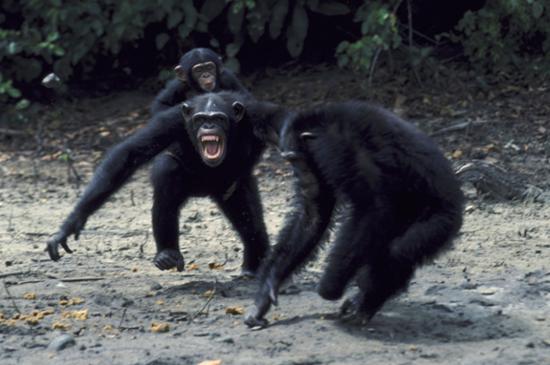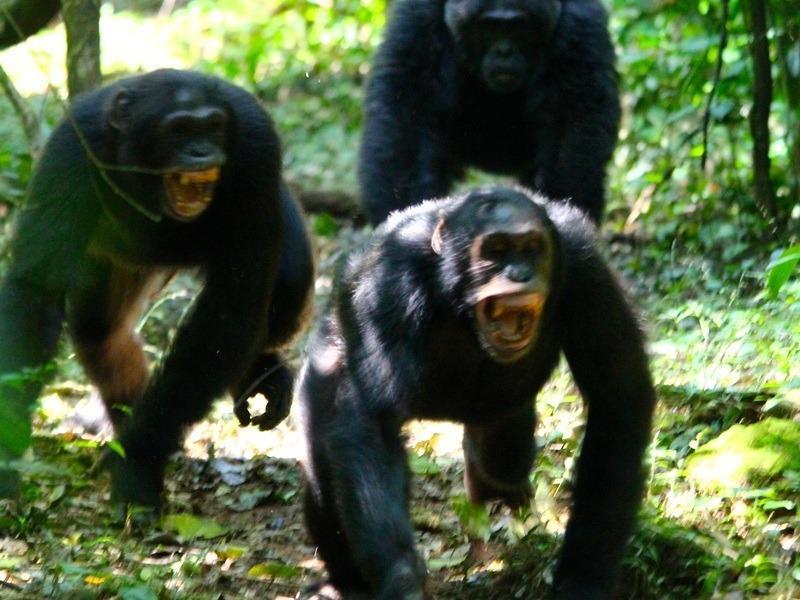The first image is the image on the left, the second image is the image on the right. For the images displayed, is the sentence "In one of the image there are 3 chimpanzees on a branch." factually correct? Answer yes or no. No. The first image is the image on the left, the second image is the image on the right. Examine the images to the left and right. Is the description "The image on the left contains three chimpanzees." accurate? Answer yes or no. Yes. 